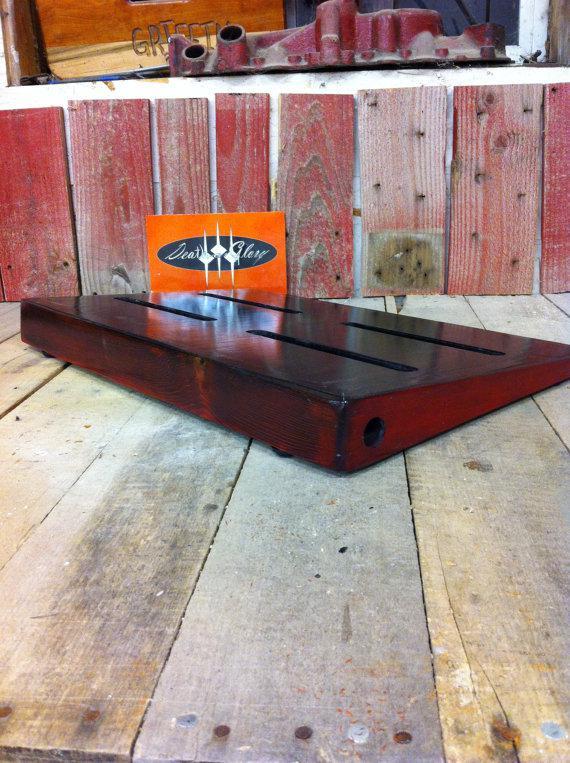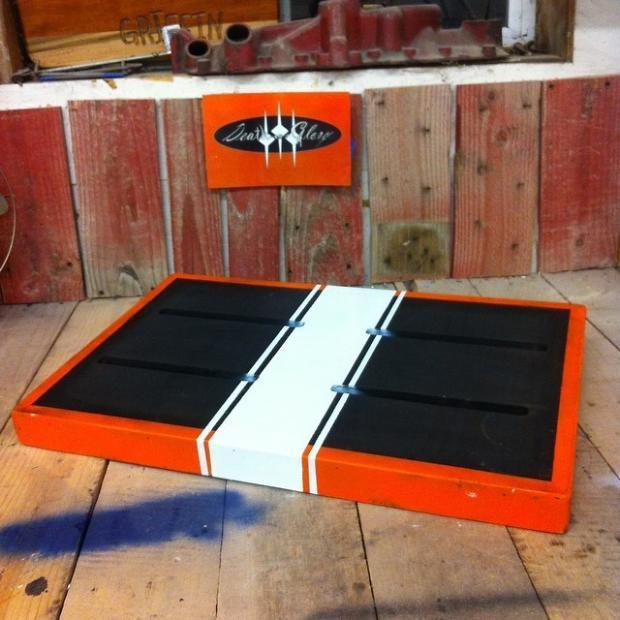The first image is the image on the left, the second image is the image on the right. Evaluate the accuracy of this statement regarding the images: "The left and right image contains the same number of orange rectangle blocks with three white dots.". Is it true? Answer yes or no. Yes. The first image is the image on the left, the second image is the image on the right. For the images displayed, is the sentence "Both items are sitting on wood planks." factually correct? Answer yes or no. Yes. 